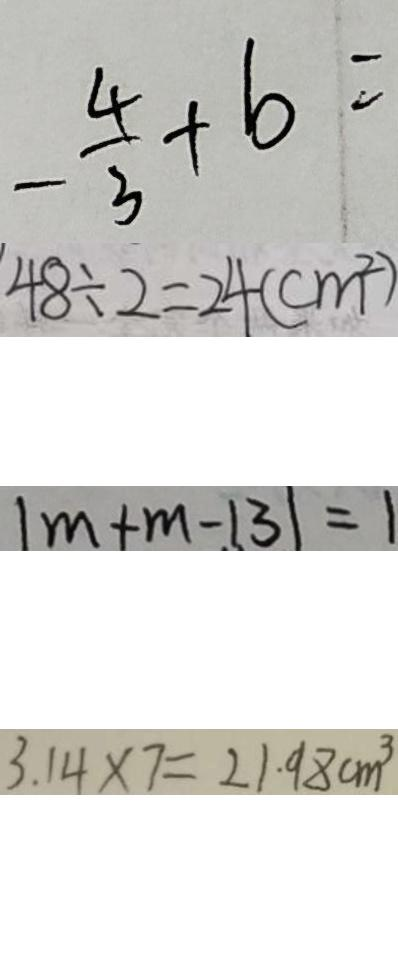<formula> <loc_0><loc_0><loc_500><loc_500>- \frac { 4 } { 3 } + b = 
 4 8 \div 2 = 2 4 ( c m ^ { 2 } ) 
 \vert m + m - 1 3 \vert = 1 
 3 . 1 4 \times 7 = 2 1 . 9 8 c m ^ { 3 }</formula> 